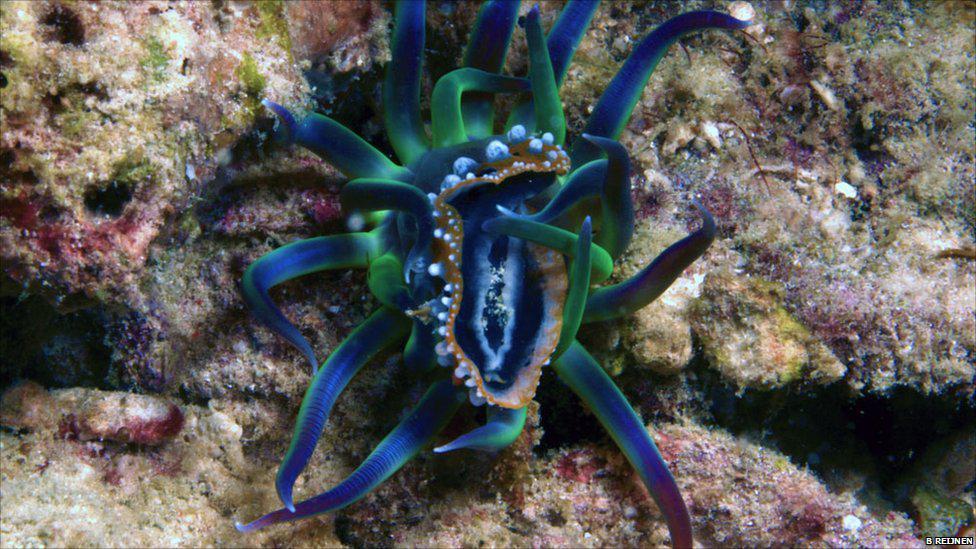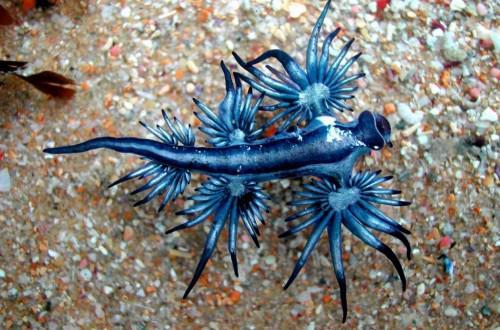The first image is the image on the left, the second image is the image on the right. For the images shown, is this caption "The creatures in each image are the same color" true? Answer yes or no. Yes. The first image is the image on the left, the second image is the image on the right. Assess this claim about the two images: "At least one image shows an anemone-type creature with tendrils in ombre green, blue and purple shades.". Correct or not? Answer yes or no. Yes. 